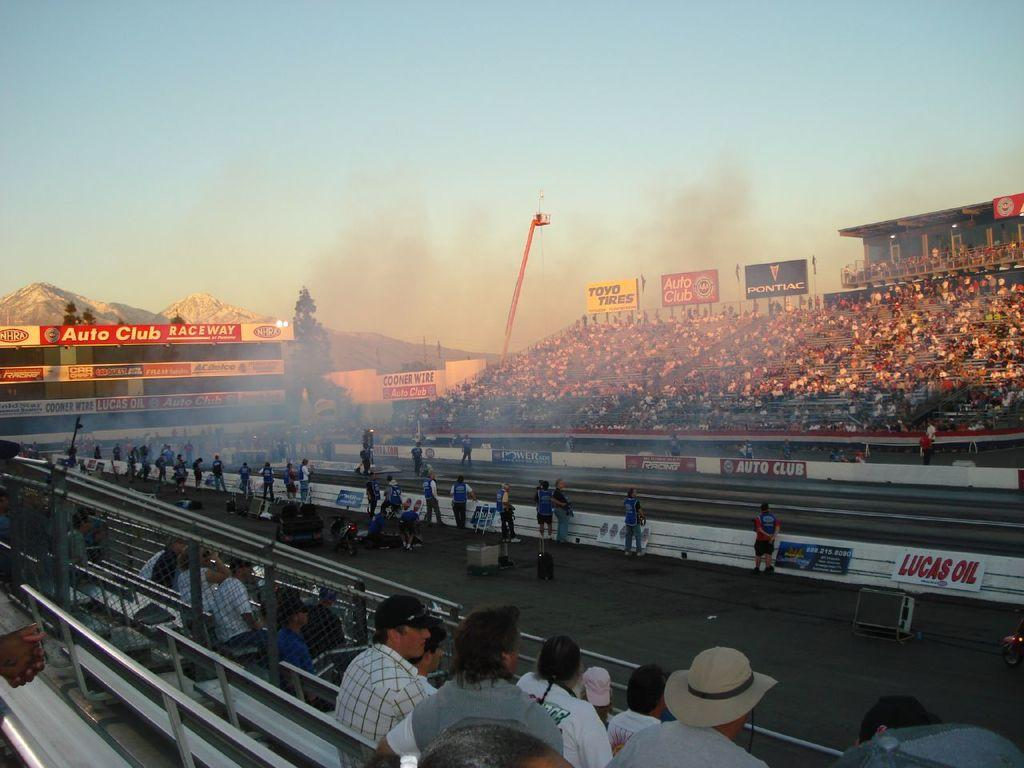What are the people in the image doing? There are people seated and standing in the image. What can be seen in the background of the image? There is a building, hills, and a blue sky visible in the image. What is the source of the smoke in the image? The source of the smoke in the image is not specified, but it could be from a construction site or a nearby fire. What is the crane used for in the image? The crane in the image is likely being used for construction or lifting heavy objects. What type of advertisements are on the hoardings in the image? The specific advertisements on the hoardings are not visible in the image. Can you see a giraffe walking on the hills in the image? No, there is no giraffe present in the image. What thrilling activity are the people participating in, as seen in the image? The image does not depict any specific thrilling activity; it simply shows people standing and seated in a location with a building, hills, and a blue sky. 